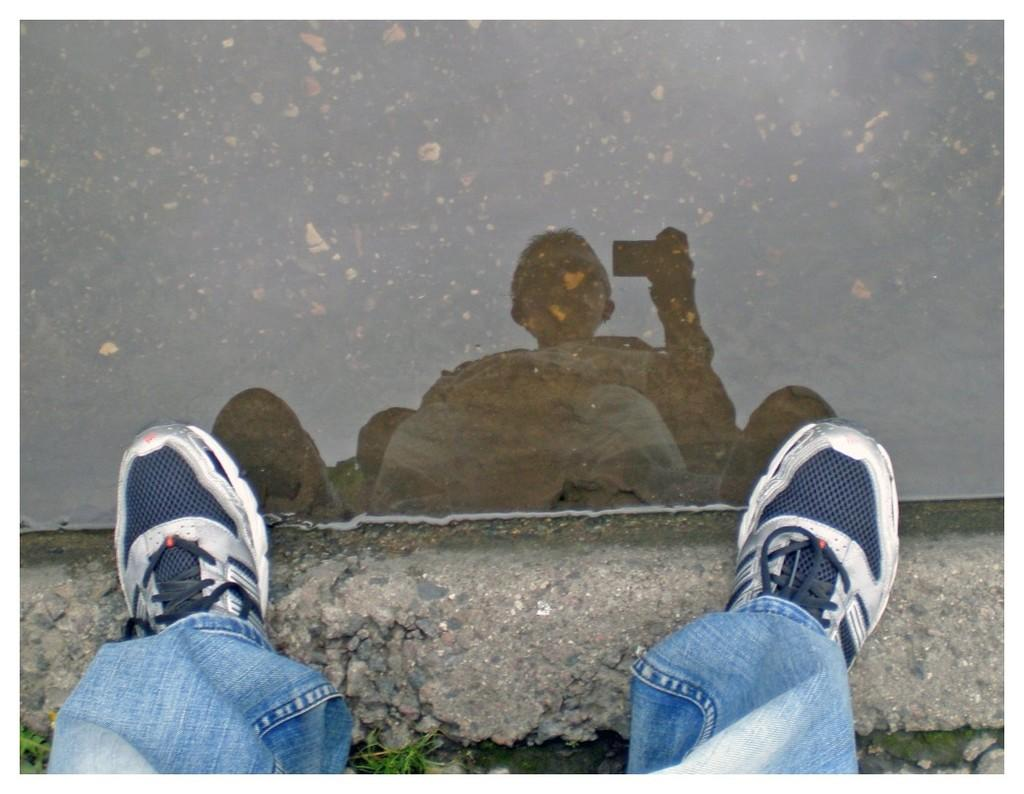What part of a person can be seen in the center of the image? There are legs of a person visible in the center of the image. What is the main feature of the image besides the person's legs? There is water in the image. What can be observed on the water's surface? There is a reflection of a person holding an object in hand on the water. What type of fruit is floating on the water in the image? There is no fruit present in the image; it features a person's legs, water, and a reflection of a person holding an object. 